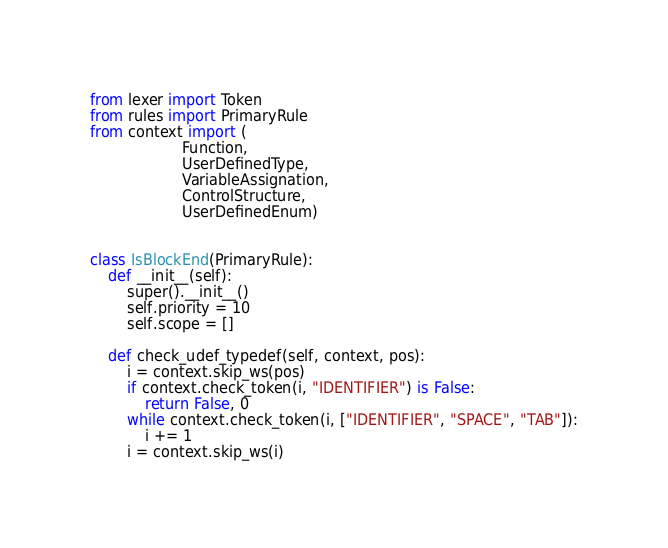<code> <loc_0><loc_0><loc_500><loc_500><_Python_>from lexer import Token
from rules import PrimaryRule
from context import (
                    Function,
                    UserDefinedType,
                    VariableAssignation,
                    ControlStructure,
                    UserDefinedEnum)


class IsBlockEnd(PrimaryRule):
    def __init__(self):
        super().__init__()
        self.priority = 10
        self.scope = []

    def check_udef_typedef(self, context, pos):
        i = context.skip_ws(pos)
        if context.check_token(i, "IDENTIFIER") is False:
            return False, 0
        while context.check_token(i, ["IDENTIFIER", "SPACE", "TAB"]):
            i += 1
        i = context.skip_ws(i)</code> 